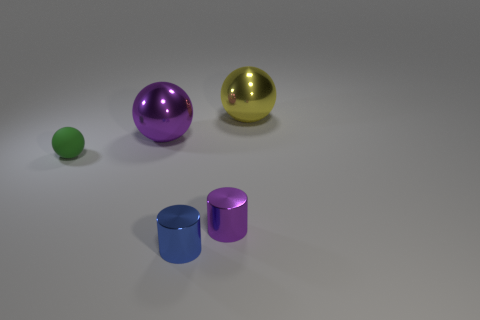Subtract all shiny balls. How many balls are left? 1 Subtract 1 balls. How many balls are left? 2 Add 2 tiny green cubes. How many objects exist? 7 Subtract all cylinders. How many objects are left? 3 Subtract 0 purple cubes. How many objects are left? 5 Subtract all brown spheres. Subtract all red cubes. How many spheres are left? 3 Subtract all tiny green metallic blocks. Subtract all yellow objects. How many objects are left? 4 Add 5 blue cylinders. How many blue cylinders are left? 6 Add 2 small yellow objects. How many small yellow objects exist? 2 